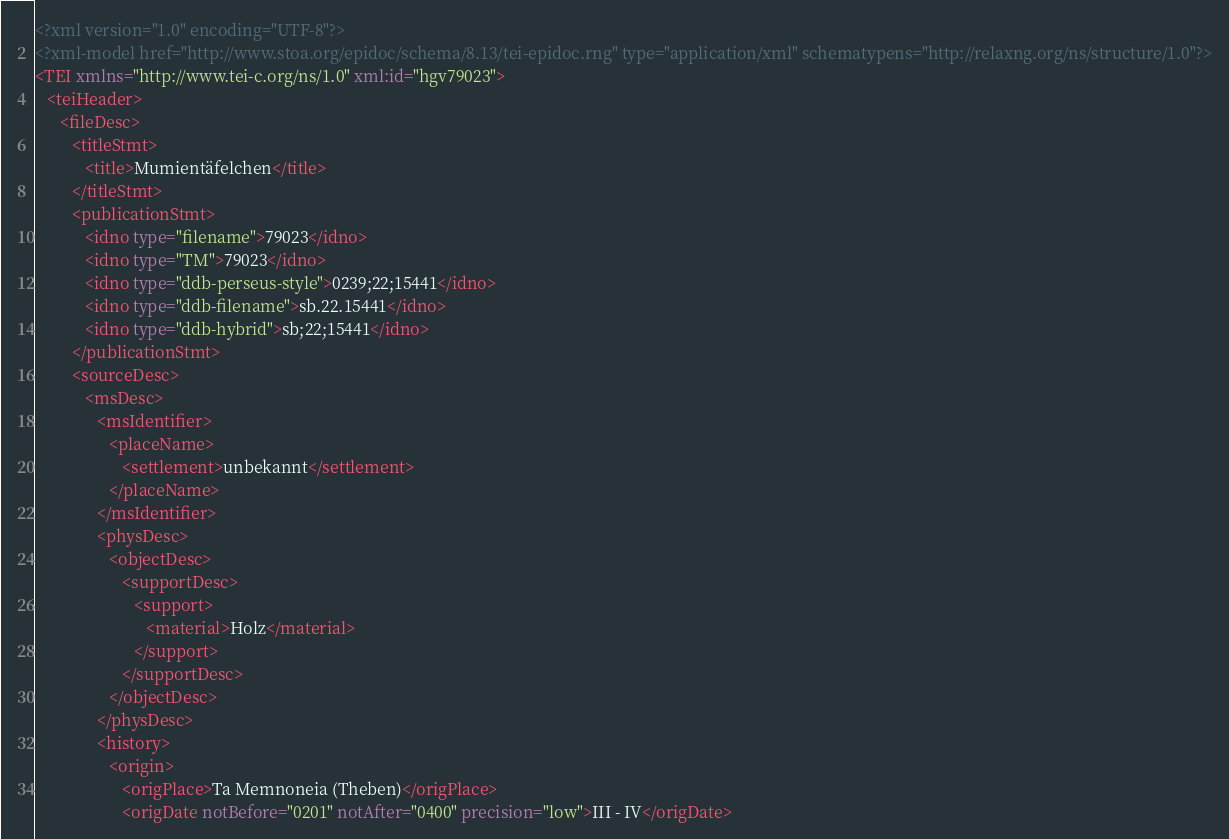Convert code to text. <code><loc_0><loc_0><loc_500><loc_500><_XML_><?xml version="1.0" encoding="UTF-8"?>
<?xml-model href="http://www.stoa.org/epidoc/schema/8.13/tei-epidoc.rng" type="application/xml" schematypens="http://relaxng.org/ns/structure/1.0"?>
<TEI xmlns="http://www.tei-c.org/ns/1.0" xml:id="hgv79023">
   <teiHeader>
      <fileDesc>
         <titleStmt>
            <title>Mumientäfelchen</title>
         </titleStmt>
         <publicationStmt>
            <idno type="filename">79023</idno>
            <idno type="TM">79023</idno>
            <idno type="ddb-perseus-style">0239;22;15441</idno>
            <idno type="ddb-filename">sb.22.15441</idno>
            <idno type="ddb-hybrid">sb;22;15441</idno>
         </publicationStmt>
         <sourceDesc>
            <msDesc>
               <msIdentifier>
                  <placeName>
                     <settlement>unbekannt</settlement>
                  </placeName>
               </msIdentifier>
               <physDesc>
                  <objectDesc>
                     <supportDesc>
                        <support>
                           <material>Holz</material>
                        </support>
                     </supportDesc>
                  </objectDesc>
               </physDesc>
               <history>
                  <origin>
                     <origPlace>Ta Memnoneia (Theben)</origPlace>
                     <origDate notBefore="0201" notAfter="0400" precision="low">III - IV</origDate></code> 